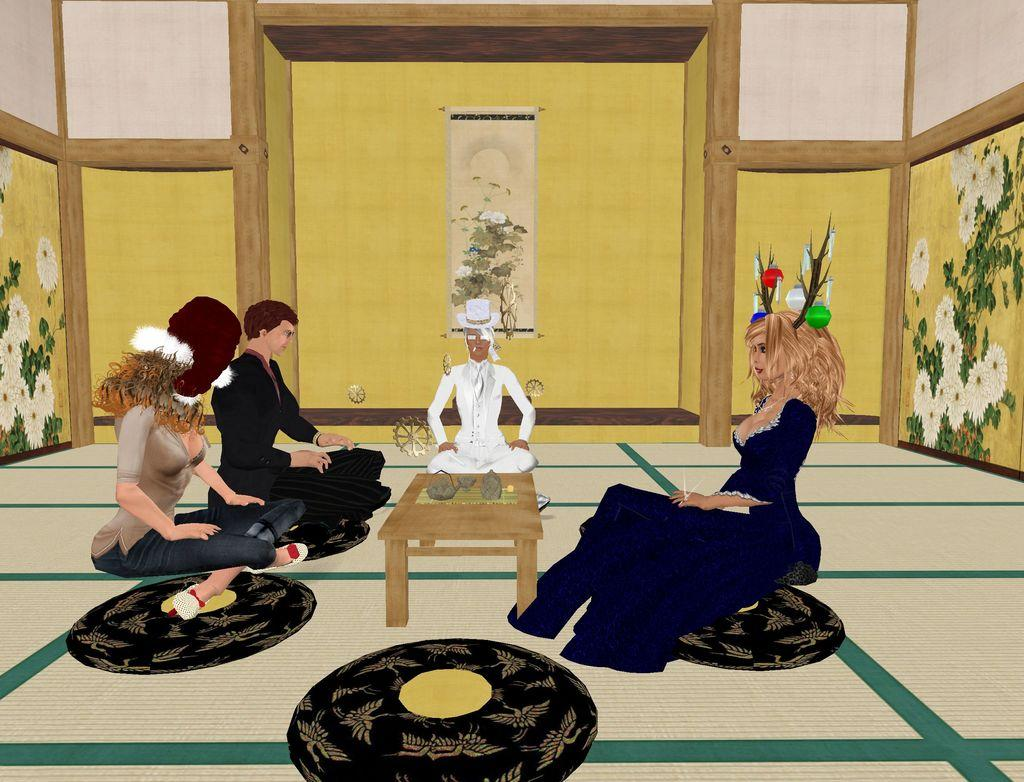What are the people in the image doing? The people are sitting on the floor mat in the foreground of the image. What is the purpose of the table in the image? The people are gathered around a table, which suggests they might be using it for a specific activity. What can be seen on the table? There are objects on the table. What is visible in the background of the image? There is a wall in the background of the image, and a frame is mounted on the wall. What rule is being discussed by the people sitting on the floor mat in the image? There is no indication in the image that the people are discussing a rule or any specific topic. 